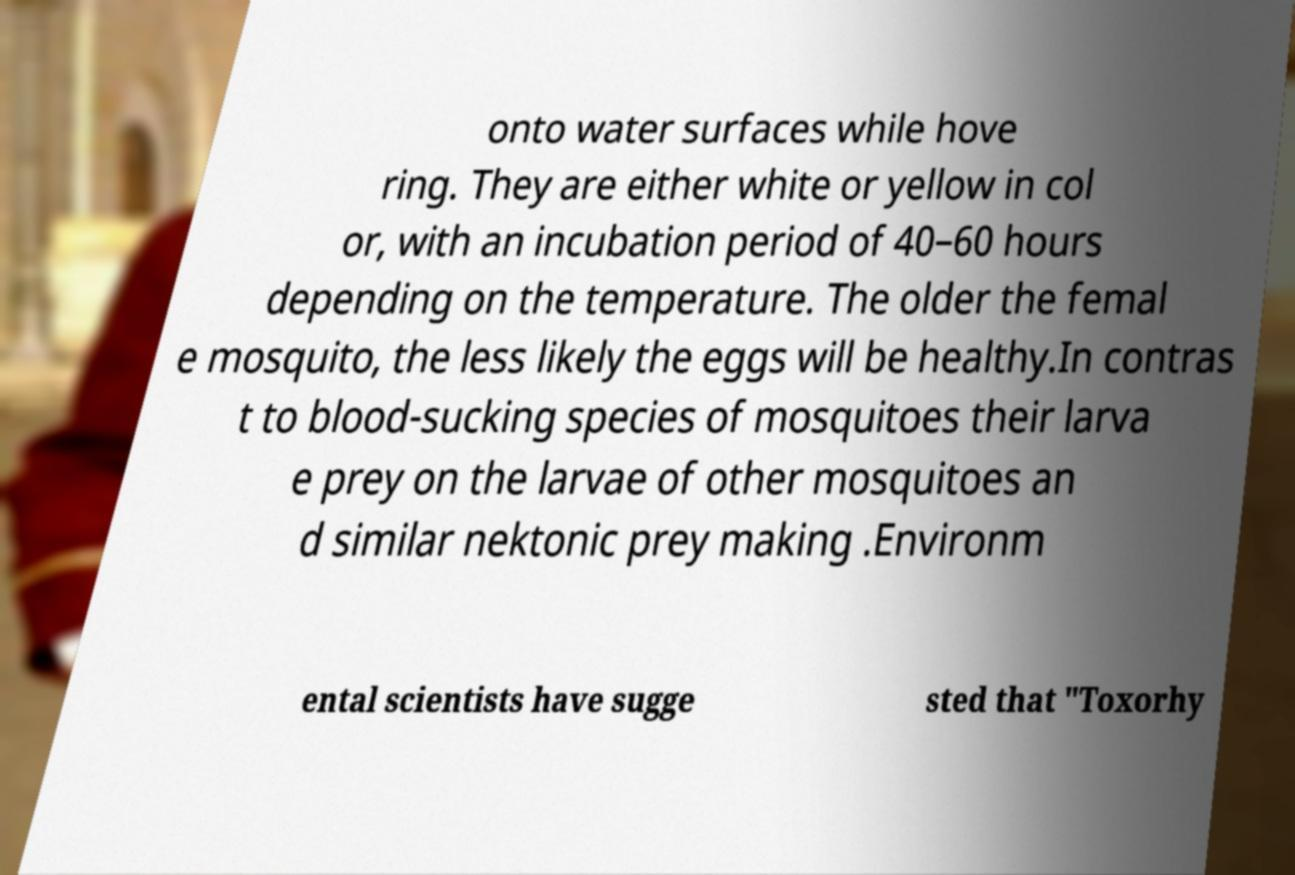Could you extract and type out the text from this image? onto water surfaces while hove ring. They are either white or yellow in col or, with an incubation period of 40–60 hours depending on the temperature. The older the femal e mosquito, the less likely the eggs will be healthy.In contras t to blood-sucking species of mosquitoes their larva e prey on the larvae of other mosquitoes an d similar nektonic prey making .Environm ental scientists have sugge sted that "Toxorhy 